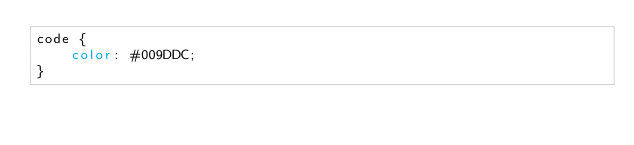Convert code to text. <code><loc_0><loc_0><loc_500><loc_500><_CSS_>code {
    color: #009DDC;
}</code> 